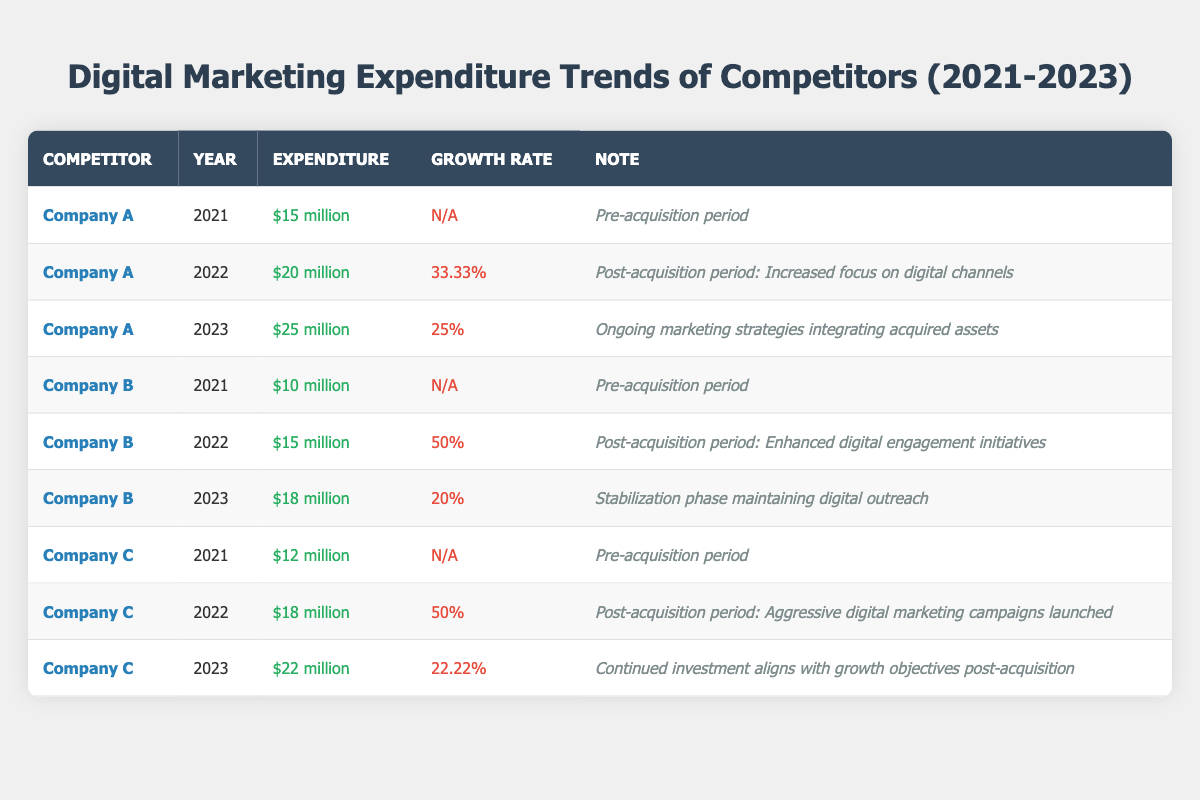What was Company A's digital marketing expenditure in 2022? The table shows that Company A had an expenditure of $20 million in 2022.
Answer: $20 million What is the growth rate of Company B's digital marketing expenditure from 2021 to 2022? The growth rate from 2021's $10 million to 2022's $15 million is calculated as ((15 - 10) / 10) * 100 = 50%.
Answer: 50% Which competitor had the highest expenditure in 2023? By checking the expenditures for each competitor in 2023, Company A spent $25 million, Company B spent $18 million, and Company C spent $22 million; thus, Company A had the highest.
Answer: Company A Did Company C's expenditure increase in 2023 compared to 2022? Comparing Company C's expenditures, it was $18 million in 2022 and $22 million in 2023, which is an increase.
Answer: Yes What was the average digital marketing expenditure for Company A from 2021 to 2023? The total expenditure for Company A is $15 million (2021) + $20 million (2022) + $25 million (2023) = $60 million. There are three years, so the average is $60 million / 3 = $20 million.
Answer: $20 million What percentage growth did Company C experience from 2021 to 2022? Company C's expenditure was $12 million in 2021 and $18 million in 2022. Calculating the growth: ((18 - 12) / 12) * 100 = 50%.
Answer: 50% What was the total digital marketing expenditure for Company B from 2021 to 2023? The total expenditure is $10 million (2021) + $15 million (2022) + $18 million (2023) = $43 million.
Answer: $43 million Which competitor had a growth rate lower than 25% in 2023? In 2023, Company A had a 25% growth rate, Company B had 20%, and Company C had 22.22%. Therefore, Company B's growth rate was lower than 25%.
Answer: Company B For which competitor did the expenditure grow the most from 2021 to 2022? The growth from 2021 to 2022 for each competitor is: Company A: 33.33%, Company B: 50%, and Company C: 50%. Both Company B and Company C had the same growth rate of 50%, which is the highest.
Answer: Company B and Company C How much more did Company A spend on digital marketing in 2023 compared to 2022? The difference between Company A's expenditures in 2023 ($25 million) and 2022 ($20 million) is $25 million - $20 million = $5 million.
Answer: $5 million Was there any year where Company B's expenditure was lower than in 2021? Company B's expenditures were $10 million in 2021, $15 million in 2022, and $18 million in 2023. Since each year's expenditure was higher than in 2021, the answer is no.
Answer: No 